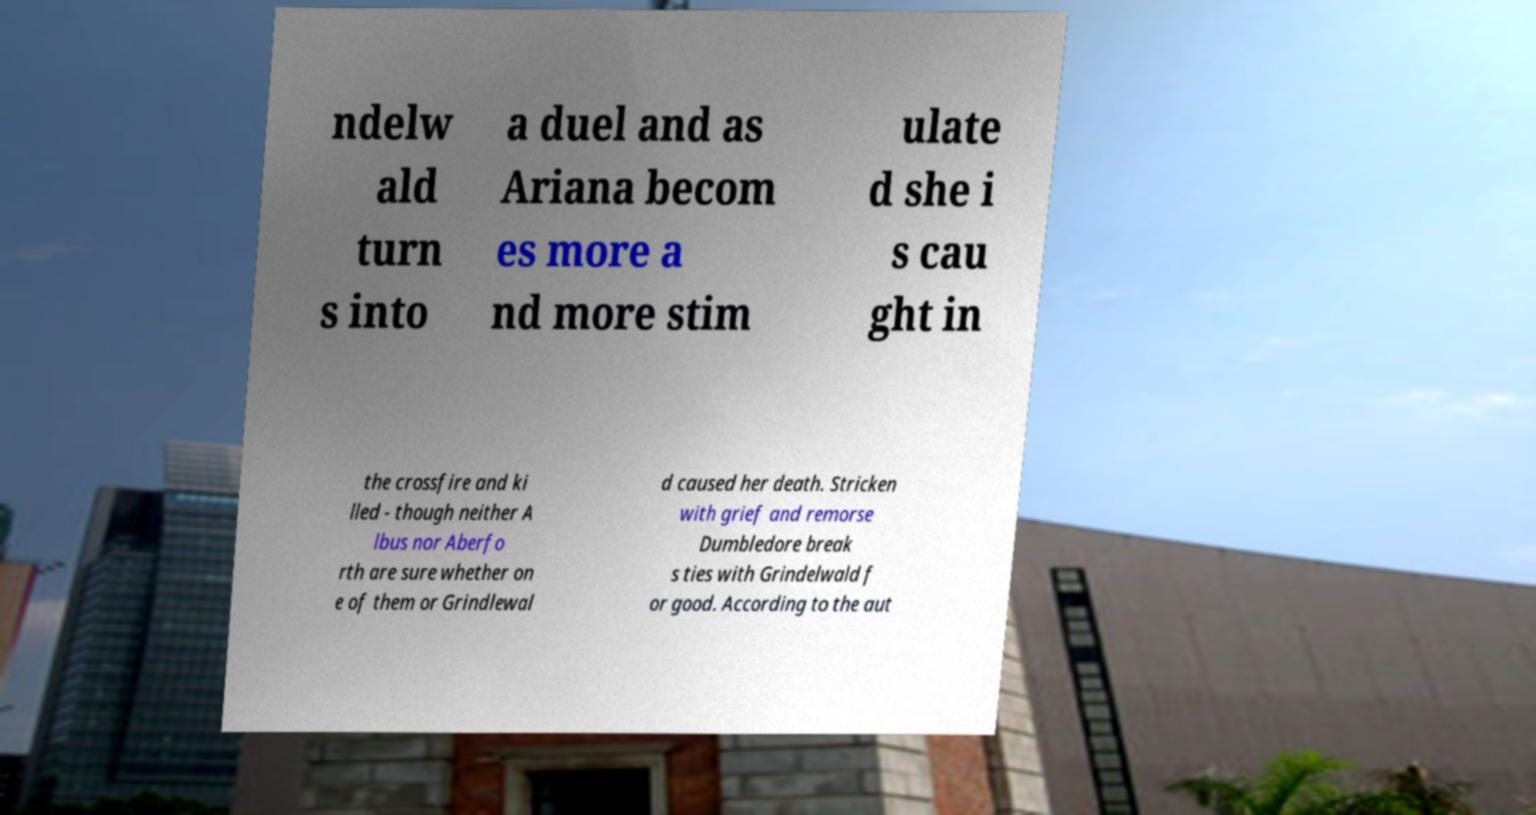What messages or text are displayed in this image? I need them in a readable, typed format. ndelw ald turn s into a duel and as Ariana becom es more a nd more stim ulate d she i s cau ght in the crossfire and ki lled - though neither A lbus nor Aberfo rth are sure whether on e of them or Grindlewal d caused her death. Stricken with grief and remorse Dumbledore break s ties with Grindelwald f or good. According to the aut 